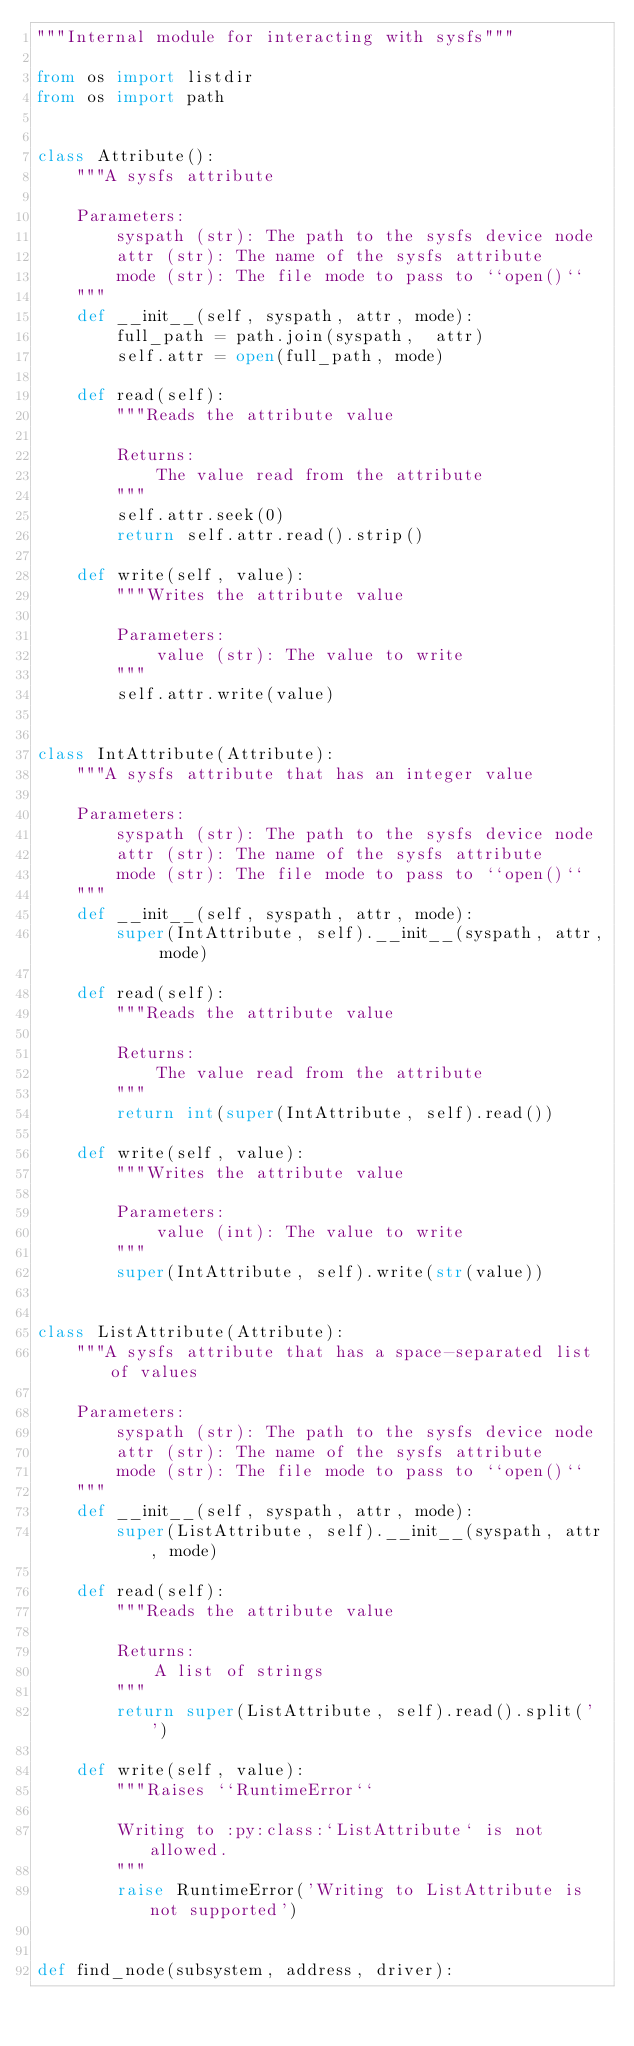Convert code to text. <code><loc_0><loc_0><loc_500><loc_500><_Python_>"""Internal module for interacting with sysfs"""

from os import listdir
from os import path


class Attribute():
    """A sysfs attribute

    Parameters:
        syspath (str): The path to the sysfs device node
        attr (str): The name of the sysfs attribute
        mode (str): The file mode to pass to ``open()``
    """
    def __init__(self, syspath, attr, mode):
        full_path = path.join(syspath,  attr)
        self.attr = open(full_path, mode)

    def read(self):
        """Reads the attribute value

        Returns:
            The value read from the attribute
        """
        self.attr.seek(0)
        return self.attr.read().strip()

    def write(self, value):
        """Writes the attribute value

        Parameters:
            value (str): The value to write
        """
        self.attr.write(value)


class IntAttribute(Attribute):
    """A sysfs attribute that has an integer value

    Parameters:
        syspath (str): The path to the sysfs device node
        attr (str): The name of the sysfs attribute
        mode (str): The file mode to pass to ``open()``
    """
    def __init__(self, syspath, attr, mode):
        super(IntAttribute, self).__init__(syspath, attr, mode)

    def read(self):
        """Reads the attribute value

        Returns:
            The value read from the attribute
        """
        return int(super(IntAttribute, self).read())

    def write(self, value):
        """Writes the attribute value

        Parameters:
            value (int): The value to write
        """
        super(IntAttribute, self).write(str(value))


class ListAttribute(Attribute):
    """A sysfs attribute that has a space-separated list of values

    Parameters:
        syspath (str): The path to the sysfs device node
        attr (str): The name of the sysfs attribute
        mode (str): The file mode to pass to ``open()``
    """
    def __init__(self, syspath, attr, mode):
        super(ListAttribute, self).__init__(syspath, attr, mode)

    def read(self):
        """Reads the attribute value

        Returns:
            A list of strings
        """
        return super(ListAttribute, self).read().split(' ')

    def write(self, value):
        """Raises ``RuntimeError``

        Writing to :py:class:`ListAttribute` is not allowed.
        """
        raise RuntimeError('Writing to ListAttribute is not supported')


def find_node(subsystem, address, driver):</code> 